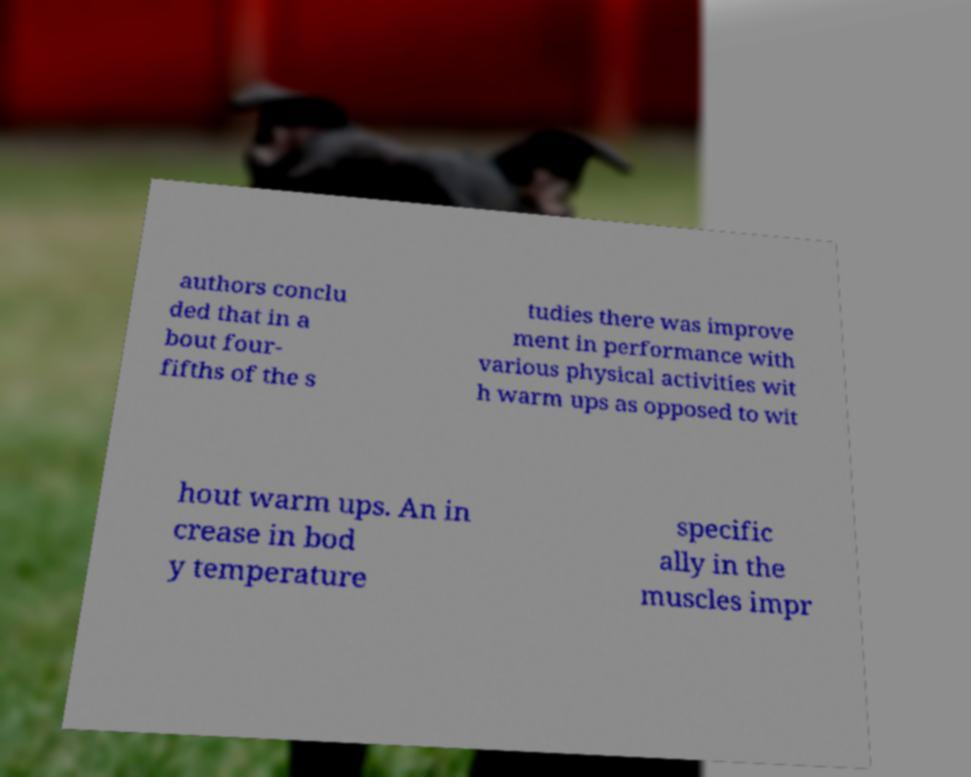Can you accurately transcribe the text from the provided image for me? authors conclu ded that in a bout four- fifths of the s tudies there was improve ment in performance with various physical activities wit h warm ups as opposed to wit hout warm ups. An in crease in bod y temperature specific ally in the muscles impr 